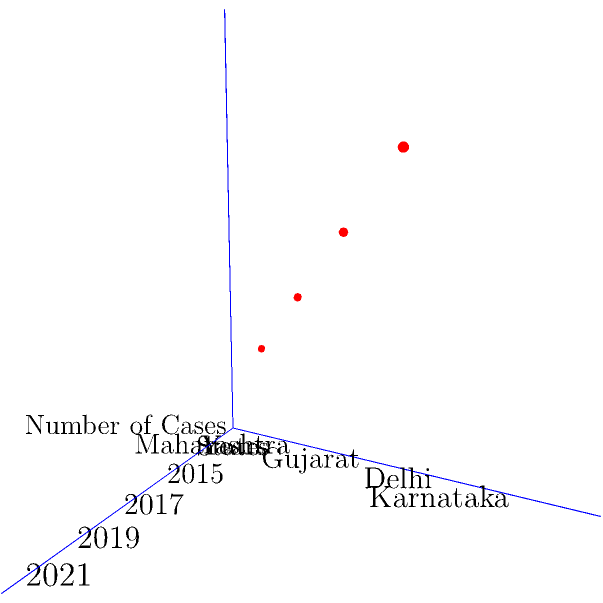Based on the 3D coordinate system representing the number of cases filed in different Indian states over time, which state shows the highest increase in case filings from 2015 to 2021? To determine which state shows the highest increase in case filings from 2015 to 2021, we need to analyze the data points for each state:

1. Identify the states:
   - The y-axis represents different states: Maharashtra, Gujarat, Delhi, and Karnataka.

2. Identify the years:
   - The x-axis represents years: 2015, 2017, 2019, and 2021.

3. Analyze the number of cases (z-axis) for each state:
   - Maharashtra (y=1): From (2,1,3) to (8,4,9)
   - Gujarat (y=2): From (4,2,5) to (8,4,9)
   - Delhi (y=3): From (6,3,7) to (8,4,9)
   - Karnataka (y=4): Only one data point at (8,4,9)

4. Calculate the increase for each state from 2015 to 2021:
   - Maharashtra: 9 - 3 = 6
   - Gujarat: 9 - 5 = 4
   - Delhi: 9 - 7 = 2
   - Karnataka: Insufficient data (only one point)

5. Compare the increases:
   Maharashtra has the highest increase of 6 cases from 2015 to 2021.
Answer: Maharashtra 